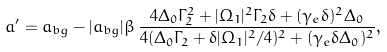Convert formula to latex. <formula><loc_0><loc_0><loc_500><loc_500>a ^ { \prime } = a _ { b g } - | a _ { b g } | \beta \, \frac { 4 \Delta _ { 0 } \Gamma _ { 2 } ^ { 2 } + | \Omega _ { 1 } | ^ { 2 } \Gamma _ { 2 } \delta + ( \gamma _ { e } \delta ) ^ { 2 } \Delta _ { 0 } } { 4 ( \Delta _ { 0 } \Gamma _ { 2 } + \delta | \Omega _ { 1 } | ^ { 2 } / 4 ) ^ { 2 } + ( \gamma _ { e } \delta \Delta _ { 0 } ) ^ { 2 } } ,</formula> 